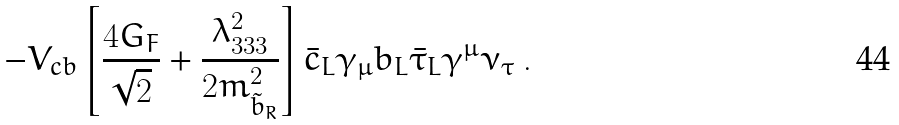<formula> <loc_0><loc_0><loc_500><loc_500>- V _ { c b } \left [ \frac { 4 G _ { F } } { \sqrt { 2 } } + \frac { \lambda _ { 3 3 3 } ^ { 2 } } { 2 m _ { \tilde { b } _ { R } } ^ { 2 } } \right ] \bar { c } _ { L } \gamma _ { \mu } b _ { L } \bar { \tau } _ { L } \gamma ^ { \mu } \nu _ { \tau } \ .</formula> 